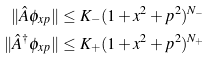Convert formula to latex. <formula><loc_0><loc_0><loc_500><loc_500>\| \hat { A } \phi _ { x p } \| & \leq K _ { - } ( 1 + x ^ { 2 } + p ^ { 2 } ) ^ { N _ { - } } \\ \| \hat { A } ^ { \dagger } \phi _ { x p } \| & \leq K _ { + } ( 1 + x ^ { 2 } + p ^ { 2 } ) ^ { N _ { + } }</formula> 